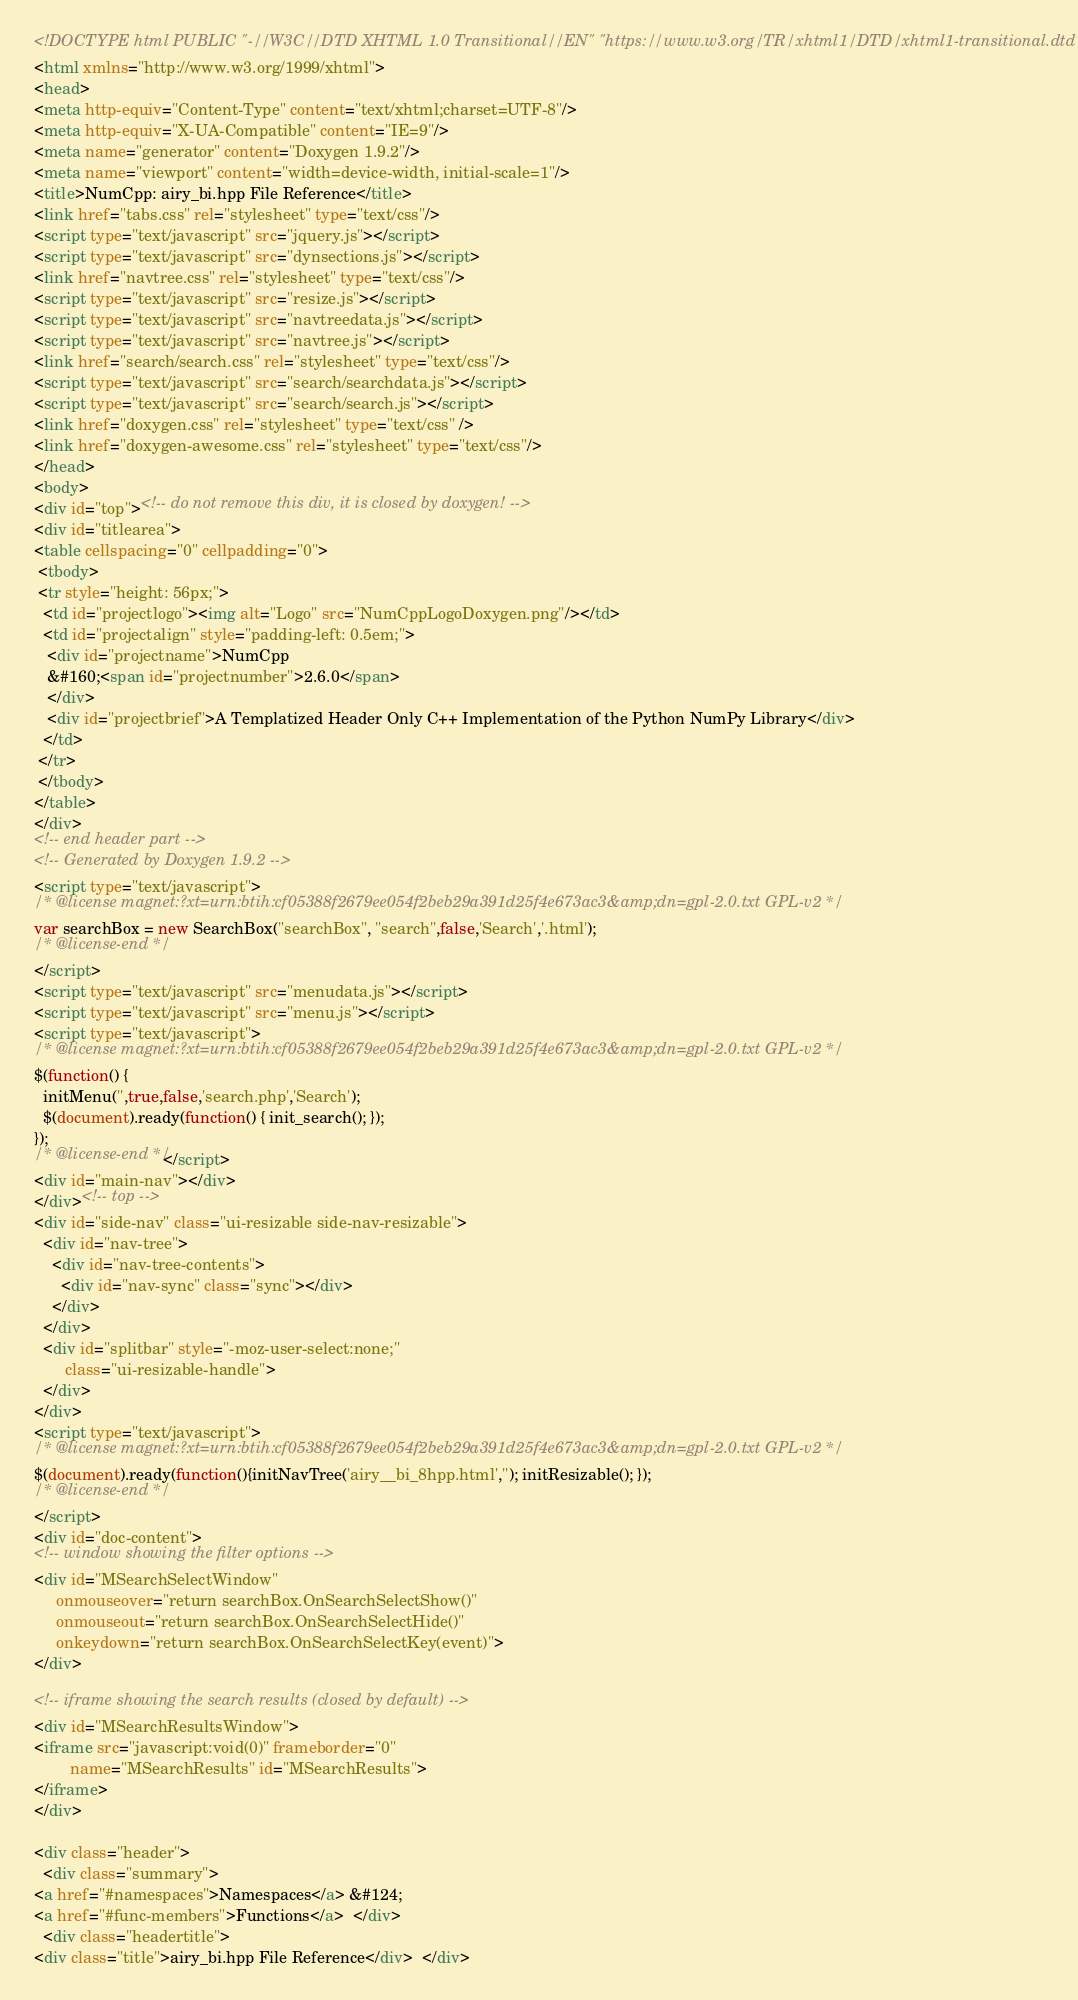<code> <loc_0><loc_0><loc_500><loc_500><_HTML_><!DOCTYPE html PUBLIC "-//W3C//DTD XHTML 1.0 Transitional//EN" "https://www.w3.org/TR/xhtml1/DTD/xhtml1-transitional.dtd">
<html xmlns="http://www.w3.org/1999/xhtml">
<head>
<meta http-equiv="Content-Type" content="text/xhtml;charset=UTF-8"/>
<meta http-equiv="X-UA-Compatible" content="IE=9"/>
<meta name="generator" content="Doxygen 1.9.2"/>
<meta name="viewport" content="width=device-width, initial-scale=1"/>
<title>NumCpp: airy_bi.hpp File Reference</title>
<link href="tabs.css" rel="stylesheet" type="text/css"/>
<script type="text/javascript" src="jquery.js"></script>
<script type="text/javascript" src="dynsections.js"></script>
<link href="navtree.css" rel="stylesheet" type="text/css"/>
<script type="text/javascript" src="resize.js"></script>
<script type="text/javascript" src="navtreedata.js"></script>
<script type="text/javascript" src="navtree.js"></script>
<link href="search/search.css" rel="stylesheet" type="text/css"/>
<script type="text/javascript" src="search/searchdata.js"></script>
<script type="text/javascript" src="search/search.js"></script>
<link href="doxygen.css" rel="stylesheet" type="text/css" />
<link href="doxygen-awesome.css" rel="stylesheet" type="text/css"/>
</head>
<body>
<div id="top"><!-- do not remove this div, it is closed by doxygen! -->
<div id="titlearea">
<table cellspacing="0" cellpadding="0">
 <tbody>
 <tr style="height: 56px;">
  <td id="projectlogo"><img alt="Logo" src="NumCppLogoDoxygen.png"/></td>
  <td id="projectalign" style="padding-left: 0.5em;">
   <div id="projectname">NumCpp
   &#160;<span id="projectnumber">2.6.0</span>
   </div>
   <div id="projectbrief">A Templatized Header Only C++ Implementation of the Python NumPy Library</div>
  </td>
 </tr>
 </tbody>
</table>
</div>
<!-- end header part -->
<!-- Generated by Doxygen 1.9.2 -->
<script type="text/javascript">
/* @license magnet:?xt=urn:btih:cf05388f2679ee054f2beb29a391d25f4e673ac3&amp;dn=gpl-2.0.txt GPL-v2 */
var searchBox = new SearchBox("searchBox", "search",false,'Search','.html');
/* @license-end */
</script>
<script type="text/javascript" src="menudata.js"></script>
<script type="text/javascript" src="menu.js"></script>
<script type="text/javascript">
/* @license magnet:?xt=urn:btih:cf05388f2679ee054f2beb29a391d25f4e673ac3&amp;dn=gpl-2.0.txt GPL-v2 */
$(function() {
  initMenu('',true,false,'search.php','Search');
  $(document).ready(function() { init_search(); });
});
/* @license-end */</script>
<div id="main-nav"></div>
</div><!-- top -->
<div id="side-nav" class="ui-resizable side-nav-resizable">
  <div id="nav-tree">
    <div id="nav-tree-contents">
      <div id="nav-sync" class="sync"></div>
    </div>
  </div>
  <div id="splitbar" style="-moz-user-select:none;" 
       class="ui-resizable-handle">
  </div>
</div>
<script type="text/javascript">
/* @license magnet:?xt=urn:btih:cf05388f2679ee054f2beb29a391d25f4e673ac3&amp;dn=gpl-2.0.txt GPL-v2 */
$(document).ready(function(){initNavTree('airy__bi_8hpp.html',''); initResizable(); });
/* @license-end */
</script>
<div id="doc-content">
<!-- window showing the filter options -->
<div id="MSearchSelectWindow"
     onmouseover="return searchBox.OnSearchSelectShow()"
     onmouseout="return searchBox.OnSearchSelectHide()"
     onkeydown="return searchBox.OnSearchSelectKey(event)">
</div>

<!-- iframe showing the search results (closed by default) -->
<div id="MSearchResultsWindow">
<iframe src="javascript:void(0)" frameborder="0" 
        name="MSearchResults" id="MSearchResults">
</iframe>
</div>

<div class="header">
  <div class="summary">
<a href="#namespaces">Namespaces</a> &#124;
<a href="#func-members">Functions</a>  </div>
  <div class="headertitle">
<div class="title">airy_bi.hpp File Reference</div>  </div></code> 